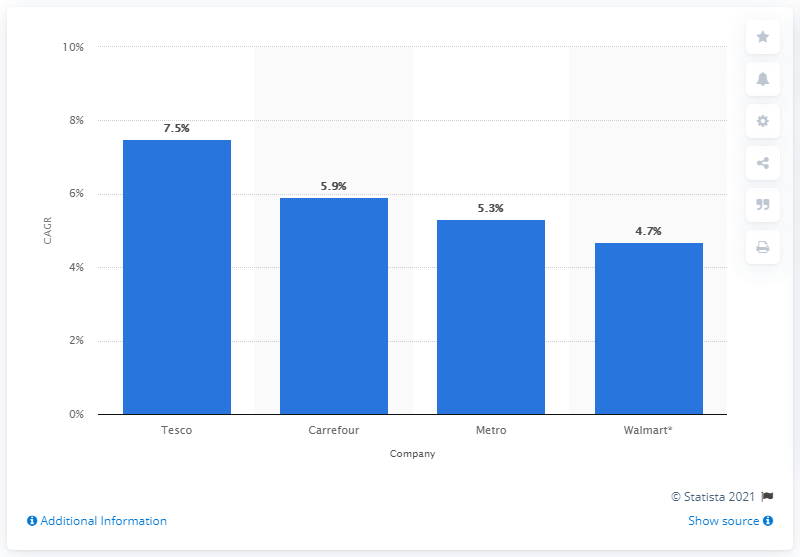Specify some key components in this picture. Tesco's estimated compound annual growth rate between 2010 and 2015 was 7.5%. 